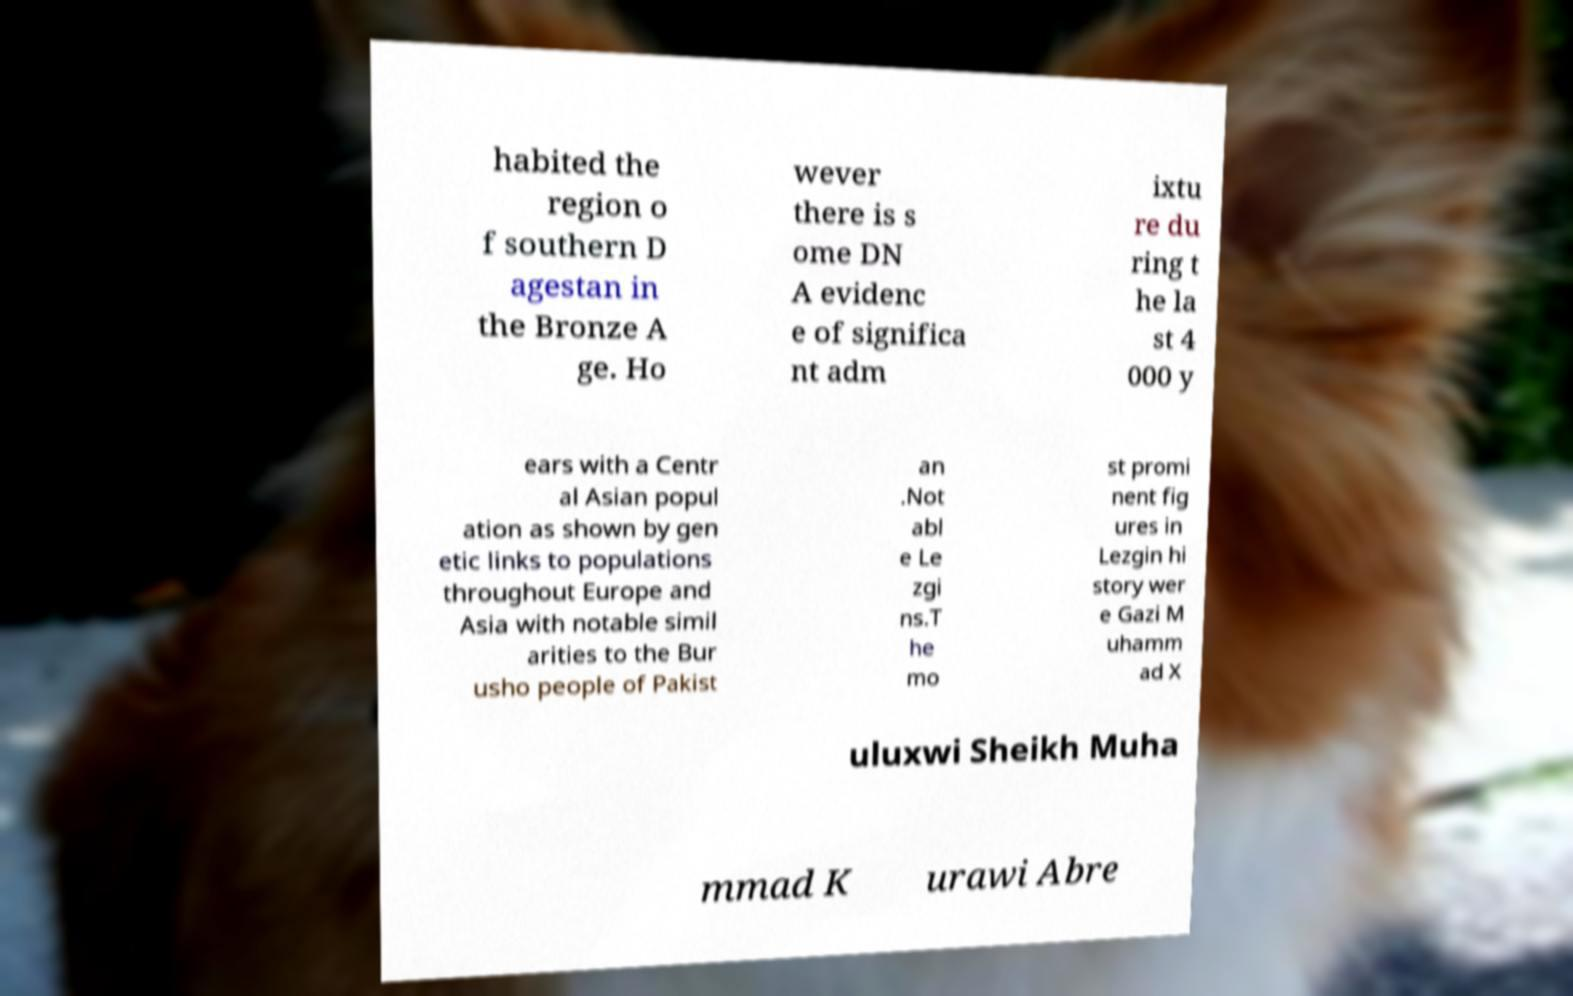Could you extract and type out the text from this image? habited the region o f southern D agestan in the Bronze A ge. Ho wever there is s ome DN A evidenc e of significa nt adm ixtu re du ring t he la st 4 000 y ears with a Centr al Asian popul ation as shown by gen etic links to populations throughout Europe and Asia with notable simil arities to the Bur usho people of Pakist an .Not abl e Le zgi ns.T he mo st promi nent fig ures in Lezgin hi story wer e Gazi M uhamm ad X uluxwi Sheikh Muha mmad K urawi Abre 